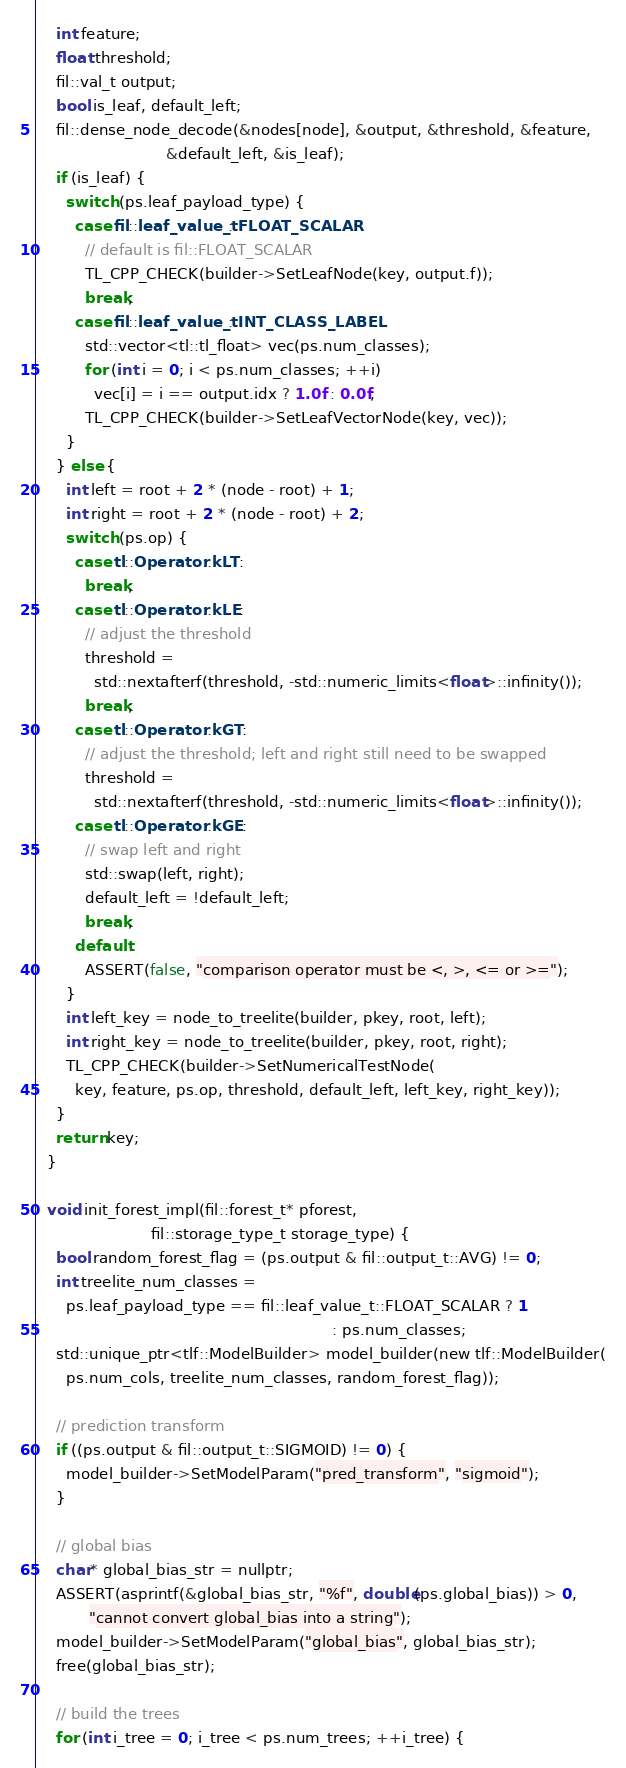Convert code to text. <code><loc_0><loc_0><loc_500><loc_500><_Cuda_>    int feature;
    float threshold;
    fil::val_t output;
    bool is_leaf, default_left;
    fil::dense_node_decode(&nodes[node], &output, &threshold, &feature,
                           &default_left, &is_leaf);
    if (is_leaf) {
      switch (ps.leaf_payload_type) {
        case fil::leaf_value_t::FLOAT_SCALAR:
          // default is fil::FLOAT_SCALAR
          TL_CPP_CHECK(builder->SetLeafNode(key, output.f));
          break;
        case fil::leaf_value_t::INT_CLASS_LABEL:
          std::vector<tl::tl_float> vec(ps.num_classes);
          for (int i = 0; i < ps.num_classes; ++i)
            vec[i] = i == output.idx ? 1.0f : 0.0f;
          TL_CPP_CHECK(builder->SetLeafVectorNode(key, vec));
      }
    } else {
      int left = root + 2 * (node - root) + 1;
      int right = root + 2 * (node - root) + 2;
      switch (ps.op) {
        case tl::Operator::kLT:
          break;
        case tl::Operator::kLE:
          // adjust the threshold
          threshold =
            std::nextafterf(threshold, -std::numeric_limits<float>::infinity());
          break;
        case tl::Operator::kGT:
          // adjust the threshold; left and right still need to be swapped
          threshold =
            std::nextafterf(threshold, -std::numeric_limits<float>::infinity());
        case tl::Operator::kGE:
          // swap left and right
          std::swap(left, right);
          default_left = !default_left;
          break;
        default:
          ASSERT(false, "comparison operator must be <, >, <= or >=");
      }
      int left_key = node_to_treelite(builder, pkey, root, left);
      int right_key = node_to_treelite(builder, pkey, root, right);
      TL_CPP_CHECK(builder->SetNumericalTestNode(
        key, feature, ps.op, threshold, default_left, left_key, right_key));
    }
    return key;
  }

  void init_forest_impl(fil::forest_t* pforest,
                        fil::storage_type_t storage_type) {
    bool random_forest_flag = (ps.output & fil::output_t::AVG) != 0;
    int treelite_num_classes =
      ps.leaf_payload_type == fil::leaf_value_t::FLOAT_SCALAR ? 1
                                                              : ps.num_classes;
    std::unique_ptr<tlf::ModelBuilder> model_builder(new tlf::ModelBuilder(
      ps.num_cols, treelite_num_classes, random_forest_flag));

    // prediction transform
    if ((ps.output & fil::output_t::SIGMOID) != 0) {
      model_builder->SetModelParam("pred_transform", "sigmoid");
    }

    // global bias
    char* global_bias_str = nullptr;
    ASSERT(asprintf(&global_bias_str, "%f", double(ps.global_bias)) > 0,
           "cannot convert global_bias into a string");
    model_builder->SetModelParam("global_bias", global_bias_str);
    free(global_bias_str);

    // build the trees
    for (int i_tree = 0; i_tree < ps.num_trees; ++i_tree) {</code> 